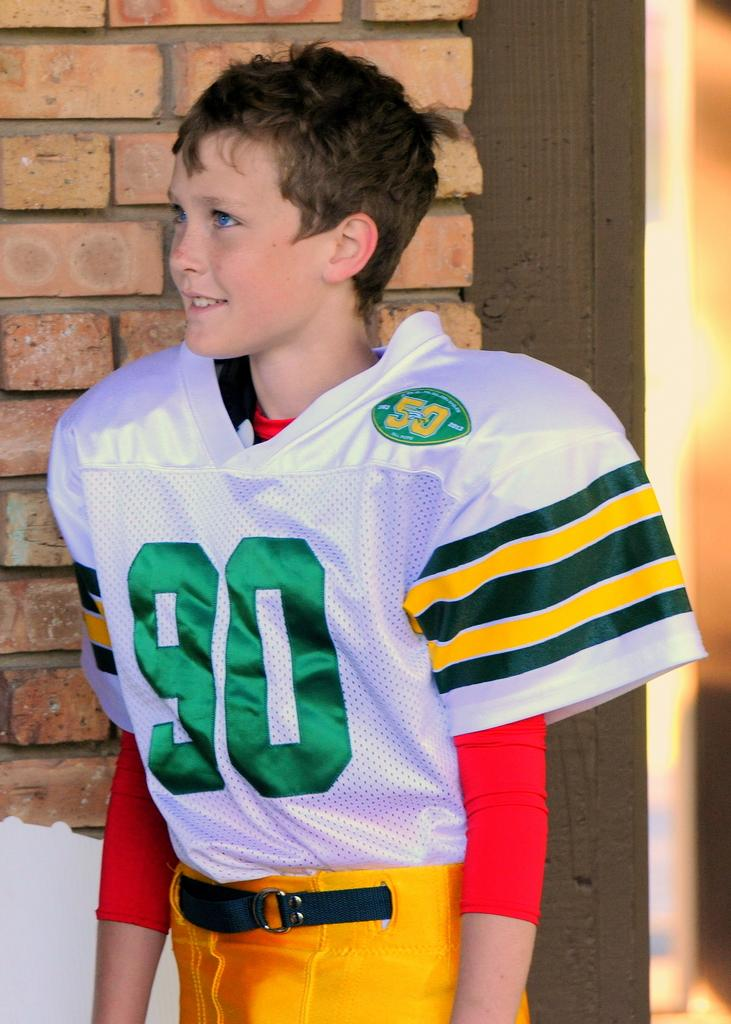<image>
Provide a brief description of the given image. a jersey that has the word 90 on it 